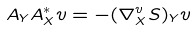<formula> <loc_0><loc_0><loc_500><loc_500>A _ { Y } A _ { X } ^ { * } v = - ( \nabla _ { X } ^ { v } S ) _ { Y } v</formula> 